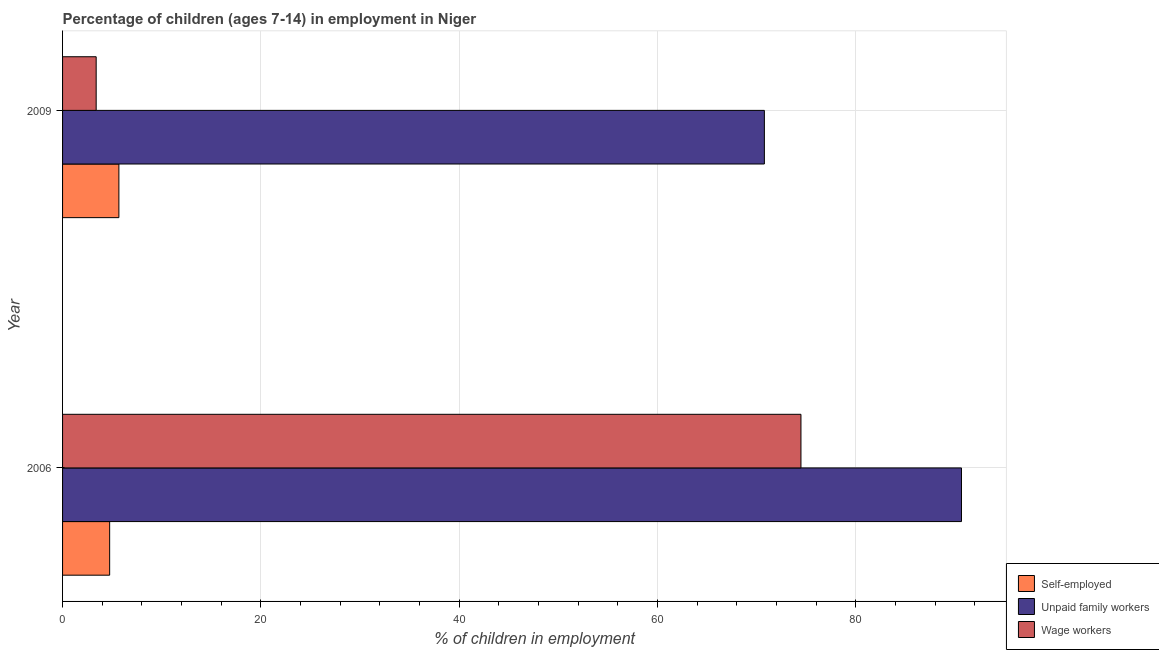How many different coloured bars are there?
Make the answer very short. 3. How many groups of bars are there?
Offer a terse response. 2. In how many cases, is the number of bars for a given year not equal to the number of legend labels?
Offer a terse response. 0. What is the percentage of children employed as unpaid family workers in 2006?
Provide a short and direct response. 90.66. Across all years, what is the maximum percentage of self employed children?
Your answer should be compact. 5.68. Across all years, what is the minimum percentage of children employed as unpaid family workers?
Offer a very short reply. 70.78. What is the total percentage of children employed as unpaid family workers in the graph?
Keep it short and to the point. 161.44. What is the difference between the percentage of self employed children in 2006 and that in 2009?
Offer a terse response. -0.93. What is the difference between the percentage of children employed as wage workers in 2006 and the percentage of self employed children in 2009?
Offer a terse response. 68.79. What is the average percentage of children employed as wage workers per year?
Provide a short and direct response. 38.93. In the year 2009, what is the difference between the percentage of self employed children and percentage of children employed as unpaid family workers?
Ensure brevity in your answer.  -65.1. What is the ratio of the percentage of self employed children in 2006 to that in 2009?
Your answer should be compact. 0.84. Is the percentage of children employed as unpaid family workers in 2006 less than that in 2009?
Your answer should be very brief. No. In how many years, is the percentage of children employed as unpaid family workers greater than the average percentage of children employed as unpaid family workers taken over all years?
Ensure brevity in your answer.  1. What does the 3rd bar from the top in 2006 represents?
Your answer should be very brief. Self-employed. What does the 1st bar from the bottom in 2009 represents?
Your answer should be very brief. Self-employed. How many bars are there?
Provide a short and direct response. 6. Are all the bars in the graph horizontal?
Your answer should be compact. Yes. How many years are there in the graph?
Your answer should be compact. 2. What is the difference between two consecutive major ticks on the X-axis?
Keep it short and to the point. 20. Are the values on the major ticks of X-axis written in scientific E-notation?
Your answer should be very brief. No. Does the graph contain any zero values?
Offer a very short reply. No. How many legend labels are there?
Provide a succinct answer. 3. What is the title of the graph?
Provide a short and direct response. Percentage of children (ages 7-14) in employment in Niger. What is the label or title of the X-axis?
Ensure brevity in your answer.  % of children in employment. What is the label or title of the Y-axis?
Your response must be concise. Year. What is the % of children in employment in Self-employed in 2006?
Keep it short and to the point. 4.75. What is the % of children in employment of Unpaid family workers in 2006?
Keep it short and to the point. 90.66. What is the % of children in employment in Wage workers in 2006?
Keep it short and to the point. 74.47. What is the % of children in employment in Self-employed in 2009?
Offer a very short reply. 5.68. What is the % of children in employment in Unpaid family workers in 2009?
Your response must be concise. 70.78. What is the % of children in employment in Wage workers in 2009?
Give a very brief answer. 3.39. Across all years, what is the maximum % of children in employment of Self-employed?
Your answer should be compact. 5.68. Across all years, what is the maximum % of children in employment of Unpaid family workers?
Your answer should be compact. 90.66. Across all years, what is the maximum % of children in employment in Wage workers?
Offer a very short reply. 74.47. Across all years, what is the minimum % of children in employment of Self-employed?
Make the answer very short. 4.75. Across all years, what is the minimum % of children in employment of Unpaid family workers?
Provide a short and direct response. 70.78. Across all years, what is the minimum % of children in employment in Wage workers?
Your response must be concise. 3.39. What is the total % of children in employment of Self-employed in the graph?
Offer a very short reply. 10.43. What is the total % of children in employment of Unpaid family workers in the graph?
Keep it short and to the point. 161.44. What is the total % of children in employment of Wage workers in the graph?
Give a very brief answer. 77.86. What is the difference between the % of children in employment in Self-employed in 2006 and that in 2009?
Ensure brevity in your answer.  -0.93. What is the difference between the % of children in employment of Unpaid family workers in 2006 and that in 2009?
Keep it short and to the point. 19.88. What is the difference between the % of children in employment of Wage workers in 2006 and that in 2009?
Your response must be concise. 71.08. What is the difference between the % of children in employment in Self-employed in 2006 and the % of children in employment in Unpaid family workers in 2009?
Offer a very short reply. -66.03. What is the difference between the % of children in employment of Self-employed in 2006 and the % of children in employment of Wage workers in 2009?
Your response must be concise. 1.36. What is the difference between the % of children in employment of Unpaid family workers in 2006 and the % of children in employment of Wage workers in 2009?
Keep it short and to the point. 87.27. What is the average % of children in employment of Self-employed per year?
Make the answer very short. 5.21. What is the average % of children in employment of Unpaid family workers per year?
Your answer should be compact. 80.72. What is the average % of children in employment in Wage workers per year?
Offer a terse response. 38.93. In the year 2006, what is the difference between the % of children in employment of Self-employed and % of children in employment of Unpaid family workers?
Offer a terse response. -85.91. In the year 2006, what is the difference between the % of children in employment of Self-employed and % of children in employment of Wage workers?
Keep it short and to the point. -69.72. In the year 2006, what is the difference between the % of children in employment in Unpaid family workers and % of children in employment in Wage workers?
Provide a succinct answer. 16.19. In the year 2009, what is the difference between the % of children in employment of Self-employed and % of children in employment of Unpaid family workers?
Provide a short and direct response. -65.1. In the year 2009, what is the difference between the % of children in employment in Self-employed and % of children in employment in Wage workers?
Your response must be concise. 2.29. In the year 2009, what is the difference between the % of children in employment of Unpaid family workers and % of children in employment of Wage workers?
Your response must be concise. 67.39. What is the ratio of the % of children in employment of Self-employed in 2006 to that in 2009?
Your response must be concise. 0.84. What is the ratio of the % of children in employment in Unpaid family workers in 2006 to that in 2009?
Your response must be concise. 1.28. What is the ratio of the % of children in employment in Wage workers in 2006 to that in 2009?
Offer a very short reply. 21.97. What is the difference between the highest and the second highest % of children in employment of Unpaid family workers?
Make the answer very short. 19.88. What is the difference between the highest and the second highest % of children in employment in Wage workers?
Your answer should be very brief. 71.08. What is the difference between the highest and the lowest % of children in employment of Self-employed?
Offer a very short reply. 0.93. What is the difference between the highest and the lowest % of children in employment of Unpaid family workers?
Ensure brevity in your answer.  19.88. What is the difference between the highest and the lowest % of children in employment of Wage workers?
Provide a succinct answer. 71.08. 